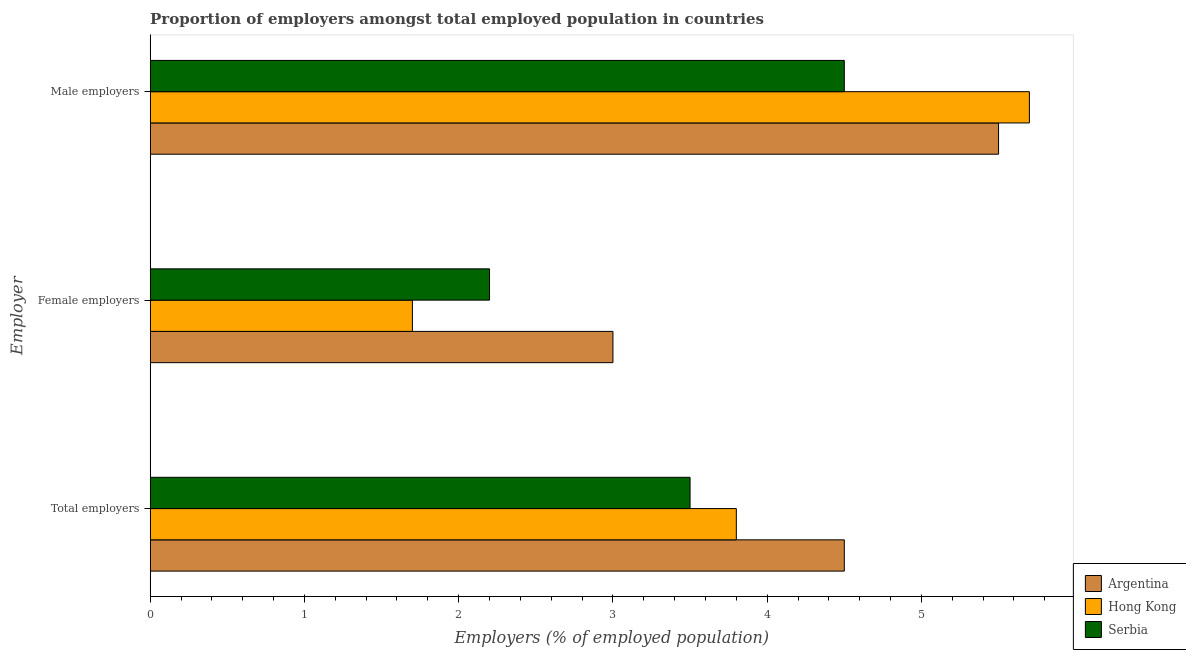How many different coloured bars are there?
Provide a succinct answer. 3. How many groups of bars are there?
Ensure brevity in your answer.  3. Are the number of bars per tick equal to the number of legend labels?
Make the answer very short. Yes. How many bars are there on the 1st tick from the bottom?
Your response must be concise. 3. What is the label of the 1st group of bars from the top?
Ensure brevity in your answer.  Male employers. What is the percentage of female employers in Serbia?
Offer a very short reply. 2.2. Across all countries, what is the maximum percentage of total employers?
Your response must be concise. 4.5. In which country was the percentage of female employers maximum?
Provide a short and direct response. Argentina. In which country was the percentage of male employers minimum?
Your response must be concise. Serbia. What is the total percentage of male employers in the graph?
Your answer should be very brief. 15.7. What is the difference between the percentage of total employers in Serbia and the percentage of female employers in Hong Kong?
Your answer should be compact. 1.8. What is the average percentage of total employers per country?
Ensure brevity in your answer.  3.93. What is the difference between the percentage of male employers and percentage of total employers in Hong Kong?
Your answer should be compact. 1.9. What is the ratio of the percentage of male employers in Hong Kong to that in Serbia?
Ensure brevity in your answer.  1.27. What is the difference between the highest and the second highest percentage of total employers?
Your answer should be very brief. 0.7. What is the difference between the highest and the lowest percentage of male employers?
Your answer should be very brief. 1.2. What does the 2nd bar from the top in Total employers represents?
Keep it short and to the point. Hong Kong. What does the 3rd bar from the bottom in Female employers represents?
Ensure brevity in your answer.  Serbia. Is it the case that in every country, the sum of the percentage of total employers and percentage of female employers is greater than the percentage of male employers?
Your answer should be compact. No. How many bars are there?
Make the answer very short. 9. Are all the bars in the graph horizontal?
Ensure brevity in your answer.  Yes. Are the values on the major ticks of X-axis written in scientific E-notation?
Your response must be concise. No. Does the graph contain grids?
Provide a short and direct response. No. How are the legend labels stacked?
Provide a succinct answer. Vertical. What is the title of the graph?
Offer a very short reply. Proportion of employers amongst total employed population in countries. Does "Vietnam" appear as one of the legend labels in the graph?
Provide a short and direct response. No. What is the label or title of the X-axis?
Keep it short and to the point. Employers (% of employed population). What is the label or title of the Y-axis?
Your response must be concise. Employer. What is the Employers (% of employed population) of Hong Kong in Total employers?
Provide a short and direct response. 3.8. What is the Employers (% of employed population) in Serbia in Total employers?
Make the answer very short. 3.5. What is the Employers (% of employed population) in Hong Kong in Female employers?
Keep it short and to the point. 1.7. What is the Employers (% of employed population) of Serbia in Female employers?
Your response must be concise. 2.2. What is the Employers (% of employed population) in Argentina in Male employers?
Ensure brevity in your answer.  5.5. What is the Employers (% of employed population) of Hong Kong in Male employers?
Your response must be concise. 5.7. Across all Employer, what is the maximum Employers (% of employed population) in Argentina?
Your answer should be very brief. 5.5. Across all Employer, what is the maximum Employers (% of employed population) of Hong Kong?
Your answer should be very brief. 5.7. Across all Employer, what is the maximum Employers (% of employed population) in Serbia?
Ensure brevity in your answer.  4.5. Across all Employer, what is the minimum Employers (% of employed population) of Hong Kong?
Make the answer very short. 1.7. Across all Employer, what is the minimum Employers (% of employed population) in Serbia?
Provide a short and direct response. 2.2. What is the total Employers (% of employed population) in Hong Kong in the graph?
Keep it short and to the point. 11.2. What is the total Employers (% of employed population) of Serbia in the graph?
Your response must be concise. 10.2. What is the difference between the Employers (% of employed population) in Hong Kong in Total employers and that in Female employers?
Provide a short and direct response. 2.1. What is the difference between the Employers (% of employed population) of Serbia in Total employers and that in Female employers?
Your response must be concise. 1.3. What is the difference between the Employers (% of employed population) of Hong Kong in Total employers and that in Male employers?
Keep it short and to the point. -1.9. What is the difference between the Employers (% of employed population) in Argentina in Female employers and that in Male employers?
Your answer should be compact. -2.5. What is the difference between the Employers (% of employed population) of Serbia in Female employers and that in Male employers?
Your response must be concise. -2.3. What is the difference between the Employers (% of employed population) of Hong Kong in Total employers and the Employers (% of employed population) of Serbia in Female employers?
Make the answer very short. 1.6. What is the difference between the Employers (% of employed population) of Argentina in Total employers and the Employers (% of employed population) of Serbia in Male employers?
Your response must be concise. 0. What is the difference between the Employers (% of employed population) in Argentina in Female employers and the Employers (% of employed population) in Hong Kong in Male employers?
Keep it short and to the point. -2.7. What is the difference between the Employers (% of employed population) in Argentina in Female employers and the Employers (% of employed population) in Serbia in Male employers?
Provide a succinct answer. -1.5. What is the difference between the Employers (% of employed population) of Hong Kong in Female employers and the Employers (% of employed population) of Serbia in Male employers?
Offer a terse response. -2.8. What is the average Employers (% of employed population) of Argentina per Employer?
Your response must be concise. 4.33. What is the average Employers (% of employed population) of Hong Kong per Employer?
Offer a terse response. 3.73. What is the average Employers (% of employed population) of Serbia per Employer?
Offer a terse response. 3.4. What is the difference between the Employers (% of employed population) in Argentina and Employers (% of employed population) in Serbia in Total employers?
Ensure brevity in your answer.  1. What is the difference between the Employers (% of employed population) in Argentina and Employers (% of employed population) in Serbia in Female employers?
Ensure brevity in your answer.  0.8. What is the difference between the Employers (% of employed population) of Hong Kong and Employers (% of employed population) of Serbia in Female employers?
Your response must be concise. -0.5. What is the difference between the Employers (% of employed population) in Argentina and Employers (% of employed population) in Serbia in Male employers?
Your answer should be very brief. 1. What is the ratio of the Employers (% of employed population) of Hong Kong in Total employers to that in Female employers?
Offer a terse response. 2.24. What is the ratio of the Employers (% of employed population) of Serbia in Total employers to that in Female employers?
Your response must be concise. 1.59. What is the ratio of the Employers (% of employed population) of Argentina in Total employers to that in Male employers?
Make the answer very short. 0.82. What is the ratio of the Employers (% of employed population) in Hong Kong in Total employers to that in Male employers?
Offer a very short reply. 0.67. What is the ratio of the Employers (% of employed population) of Serbia in Total employers to that in Male employers?
Your answer should be compact. 0.78. What is the ratio of the Employers (% of employed population) of Argentina in Female employers to that in Male employers?
Provide a short and direct response. 0.55. What is the ratio of the Employers (% of employed population) of Hong Kong in Female employers to that in Male employers?
Keep it short and to the point. 0.3. What is the ratio of the Employers (% of employed population) in Serbia in Female employers to that in Male employers?
Offer a very short reply. 0.49. What is the difference between the highest and the second highest Employers (% of employed population) of Serbia?
Give a very brief answer. 1. What is the difference between the highest and the lowest Employers (% of employed population) in Hong Kong?
Offer a very short reply. 4. What is the difference between the highest and the lowest Employers (% of employed population) in Serbia?
Ensure brevity in your answer.  2.3. 